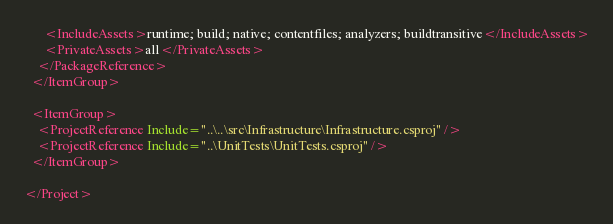Convert code to text. <code><loc_0><loc_0><loc_500><loc_500><_XML_>      <IncludeAssets>runtime; build; native; contentfiles; analyzers; buildtransitive</IncludeAssets>
      <PrivateAssets>all</PrivateAssets>
    </PackageReference>
  </ItemGroup>

  <ItemGroup>
    <ProjectReference Include="..\..\src\Infrastructure\Infrastructure.csproj" />
    <ProjectReference Include="..\UnitTests\UnitTests.csproj" />
  </ItemGroup>

</Project>
</code> 